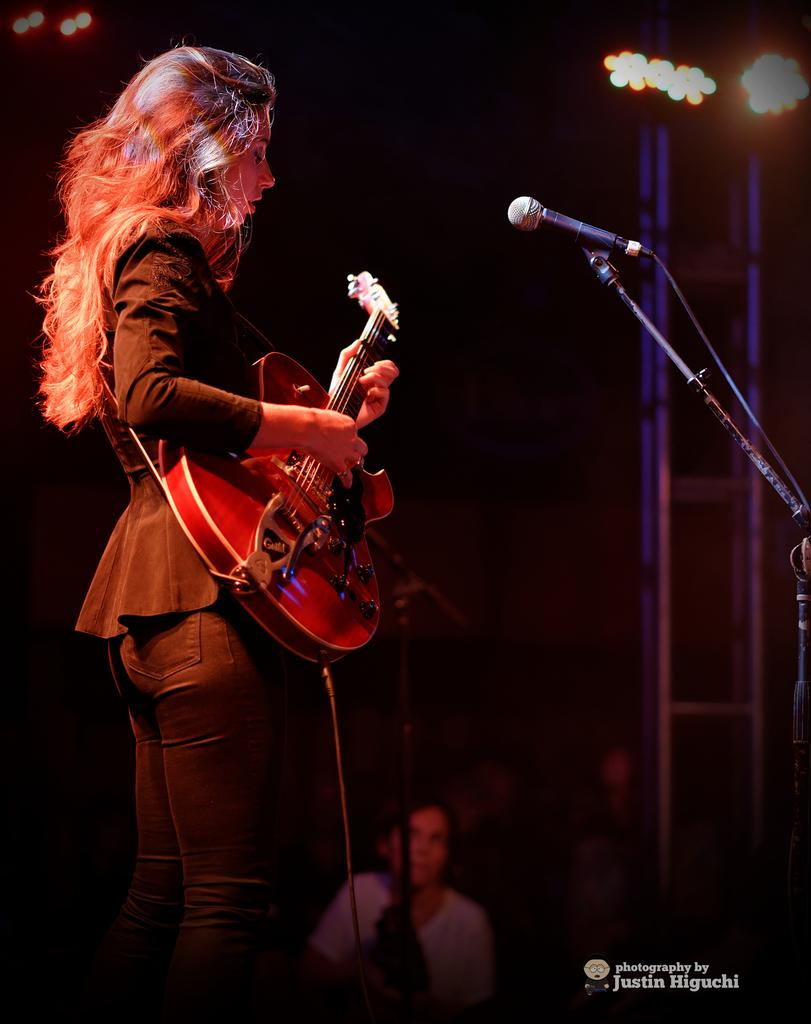Who is the main subject in the image? There is a lady in the image. What is the lady wearing? The lady is wearing a black dress. What is the lady holding in the image? The lady is holding a guitar. What is the lady doing with the guitar? The lady is playing the guitar. What is the lady standing in front of? The lady is in front of a microphone. What type of powder is being used by the lady in the image? There is no powder visible or mentioned in the image; the lady is playing a guitar in front of a microphone. 